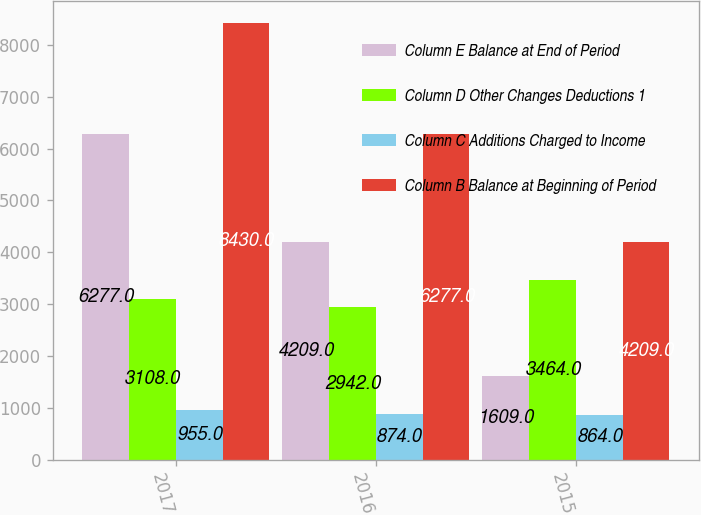Convert chart to OTSL. <chart><loc_0><loc_0><loc_500><loc_500><stacked_bar_chart><ecel><fcel>2017<fcel>2016<fcel>2015<nl><fcel>Column E Balance at End of Period<fcel>6277<fcel>4209<fcel>1609<nl><fcel>Column D Other Changes Deductions 1<fcel>3108<fcel>2942<fcel>3464<nl><fcel>Column C Additions Charged to Income<fcel>955<fcel>874<fcel>864<nl><fcel>Column B Balance at Beginning of Period<fcel>8430<fcel>6277<fcel>4209<nl></chart> 